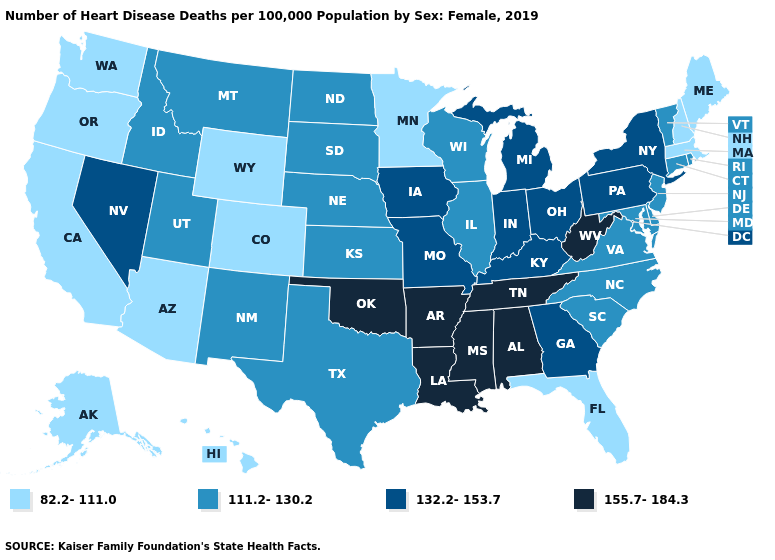Name the states that have a value in the range 111.2-130.2?
Quick response, please. Connecticut, Delaware, Idaho, Illinois, Kansas, Maryland, Montana, Nebraska, New Jersey, New Mexico, North Carolina, North Dakota, Rhode Island, South Carolina, South Dakota, Texas, Utah, Vermont, Virginia, Wisconsin. What is the value of Minnesota?
Be succinct. 82.2-111.0. Does Florida have the lowest value in the South?
Answer briefly. Yes. Among the states that border Maine , which have the highest value?
Quick response, please. New Hampshire. Does the map have missing data?
Answer briefly. No. How many symbols are there in the legend?
Keep it brief. 4. Name the states that have a value in the range 82.2-111.0?
Keep it brief. Alaska, Arizona, California, Colorado, Florida, Hawaii, Maine, Massachusetts, Minnesota, New Hampshire, Oregon, Washington, Wyoming. Name the states that have a value in the range 82.2-111.0?
Be succinct. Alaska, Arizona, California, Colorado, Florida, Hawaii, Maine, Massachusetts, Minnesota, New Hampshire, Oregon, Washington, Wyoming. What is the value of Oregon?
Quick response, please. 82.2-111.0. What is the value of North Carolina?
Concise answer only. 111.2-130.2. Does Maryland have the highest value in the USA?
Write a very short answer. No. Does Georgia have the highest value in the South?
Short answer required. No. What is the value of Delaware?
Quick response, please. 111.2-130.2. What is the highest value in the USA?
Answer briefly. 155.7-184.3. What is the highest value in the South ?
Quick response, please. 155.7-184.3. 